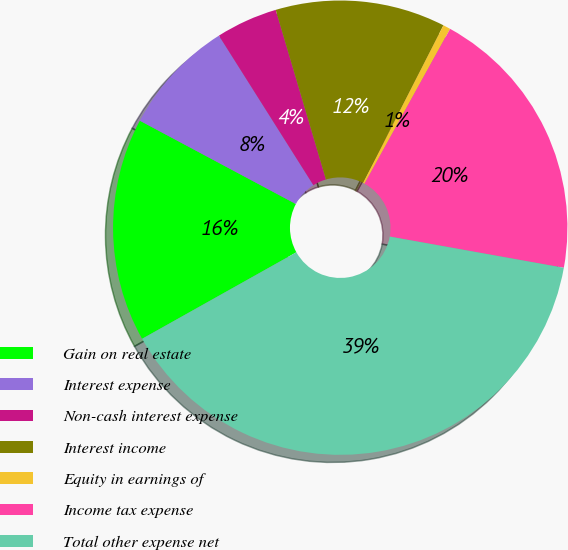Convert chart. <chart><loc_0><loc_0><loc_500><loc_500><pie_chart><fcel>Gain on real estate<fcel>Interest expense<fcel>Non-cash interest expense<fcel>Interest income<fcel>Equity in earnings of<fcel>Income tax expense<fcel>Total other expense net<nl><fcel>15.94%<fcel>8.23%<fcel>4.38%<fcel>12.09%<fcel>0.53%<fcel>19.79%<fcel>39.04%<nl></chart> 